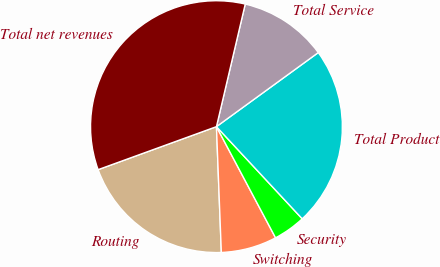<chart> <loc_0><loc_0><loc_500><loc_500><pie_chart><fcel>Routing<fcel>Switching<fcel>Security<fcel>Total Product<fcel>Total Service<fcel>Total net revenues<nl><fcel>20.07%<fcel>7.16%<fcel>4.15%<fcel>23.08%<fcel>11.32%<fcel>34.22%<nl></chart> 